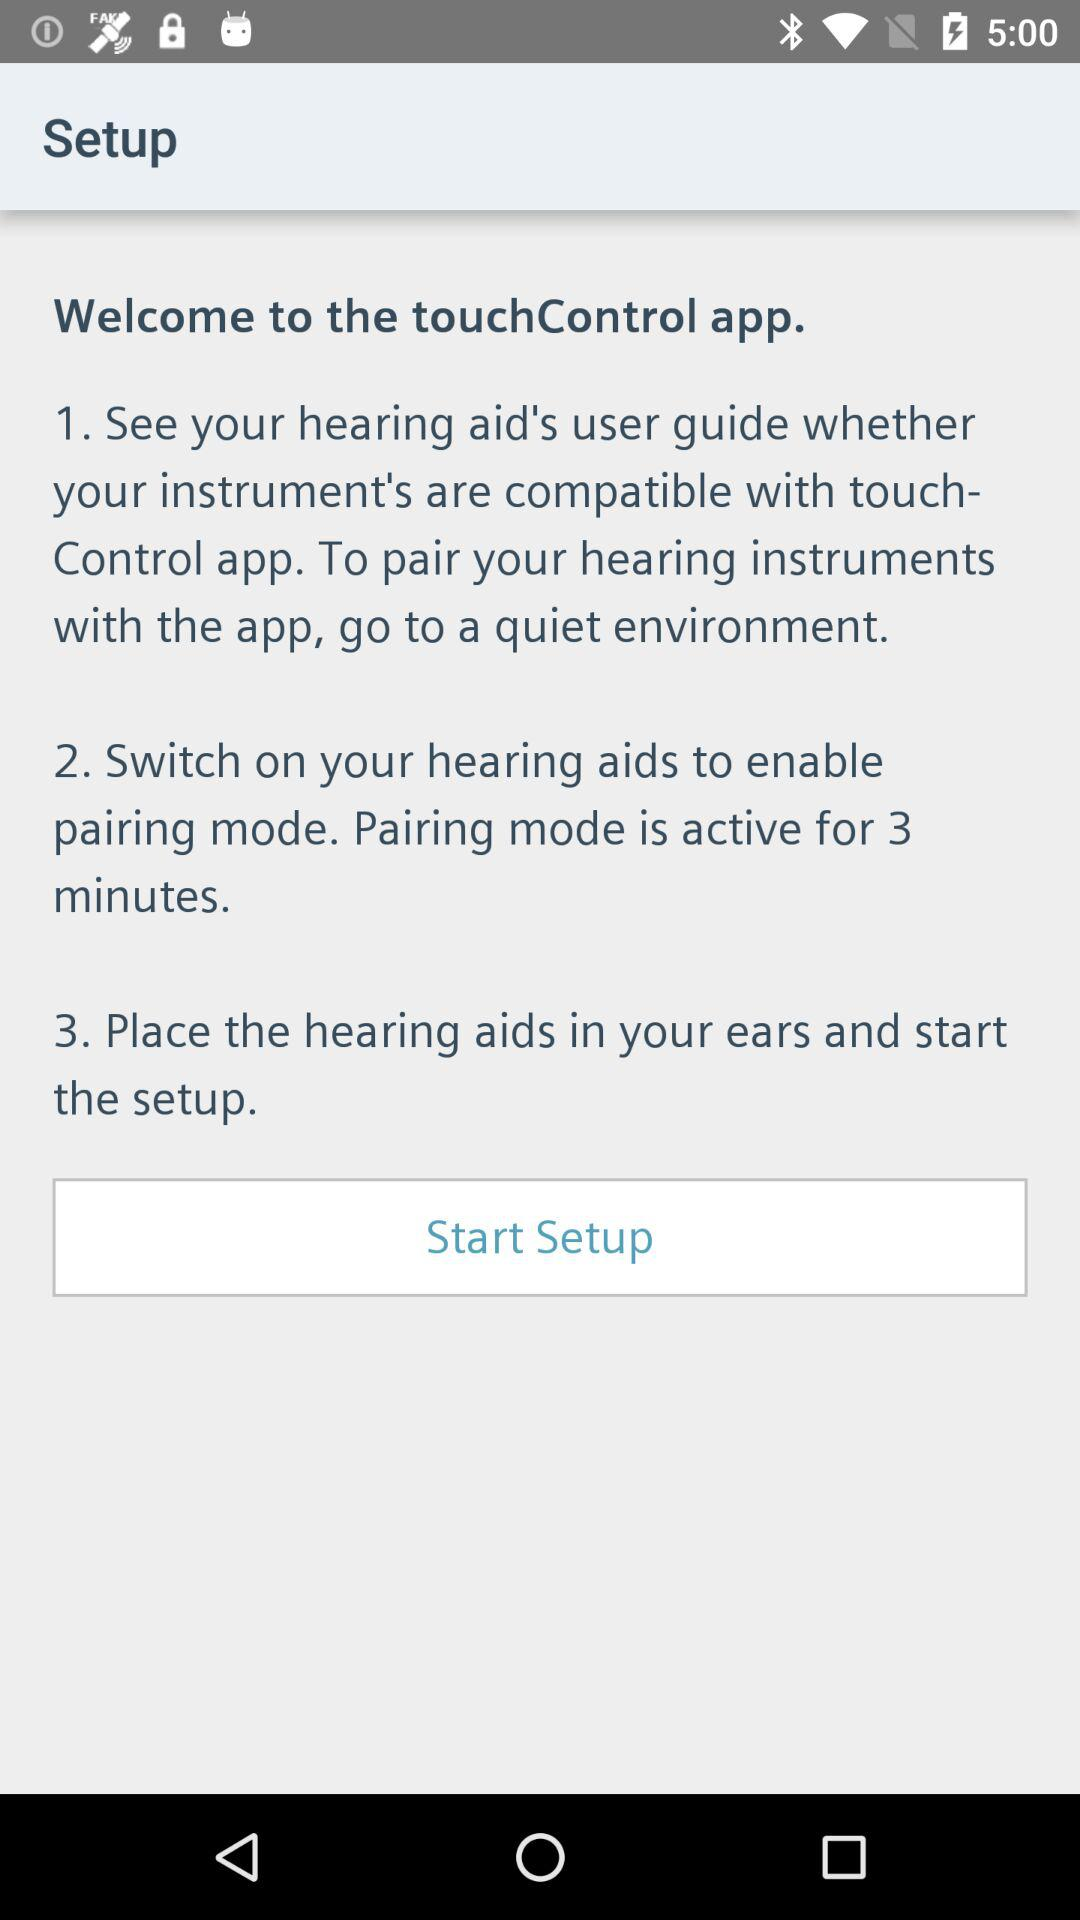What is the app name? The app name is "touchControl". 